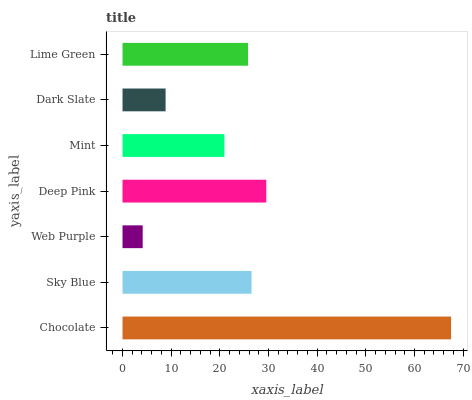Is Web Purple the minimum?
Answer yes or no. Yes. Is Chocolate the maximum?
Answer yes or no. Yes. Is Sky Blue the minimum?
Answer yes or no. No. Is Sky Blue the maximum?
Answer yes or no. No. Is Chocolate greater than Sky Blue?
Answer yes or no. Yes. Is Sky Blue less than Chocolate?
Answer yes or no. Yes. Is Sky Blue greater than Chocolate?
Answer yes or no. No. Is Chocolate less than Sky Blue?
Answer yes or no. No. Is Lime Green the high median?
Answer yes or no. Yes. Is Lime Green the low median?
Answer yes or no. Yes. Is Mint the high median?
Answer yes or no. No. Is Web Purple the low median?
Answer yes or no. No. 